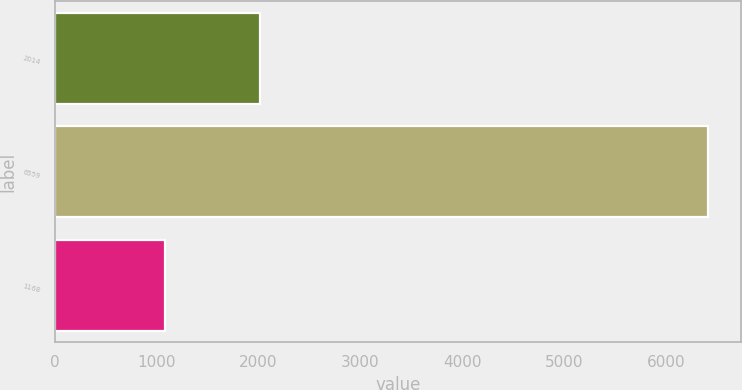Convert chart to OTSL. <chart><loc_0><loc_0><loc_500><loc_500><bar_chart><fcel>2014<fcel>6559<fcel>1168<nl><fcel>2013<fcel>6413<fcel>1084<nl></chart> 